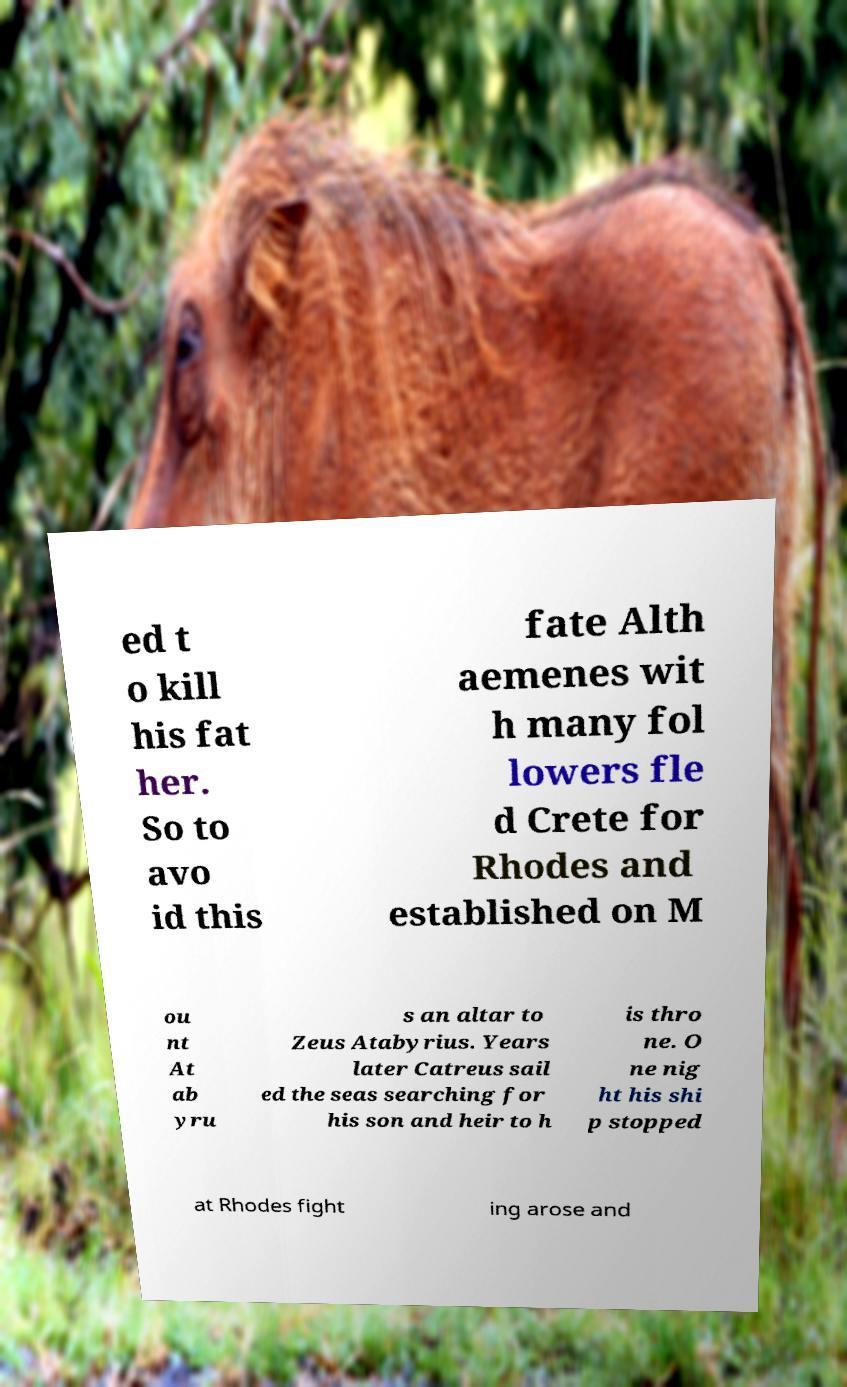There's text embedded in this image that I need extracted. Can you transcribe it verbatim? ed t o kill his fat her. So to avo id this fate Alth aemenes wit h many fol lowers fle d Crete for Rhodes and established on M ou nt At ab yru s an altar to Zeus Atabyrius. Years later Catreus sail ed the seas searching for his son and heir to h is thro ne. O ne nig ht his shi p stopped at Rhodes fight ing arose and 